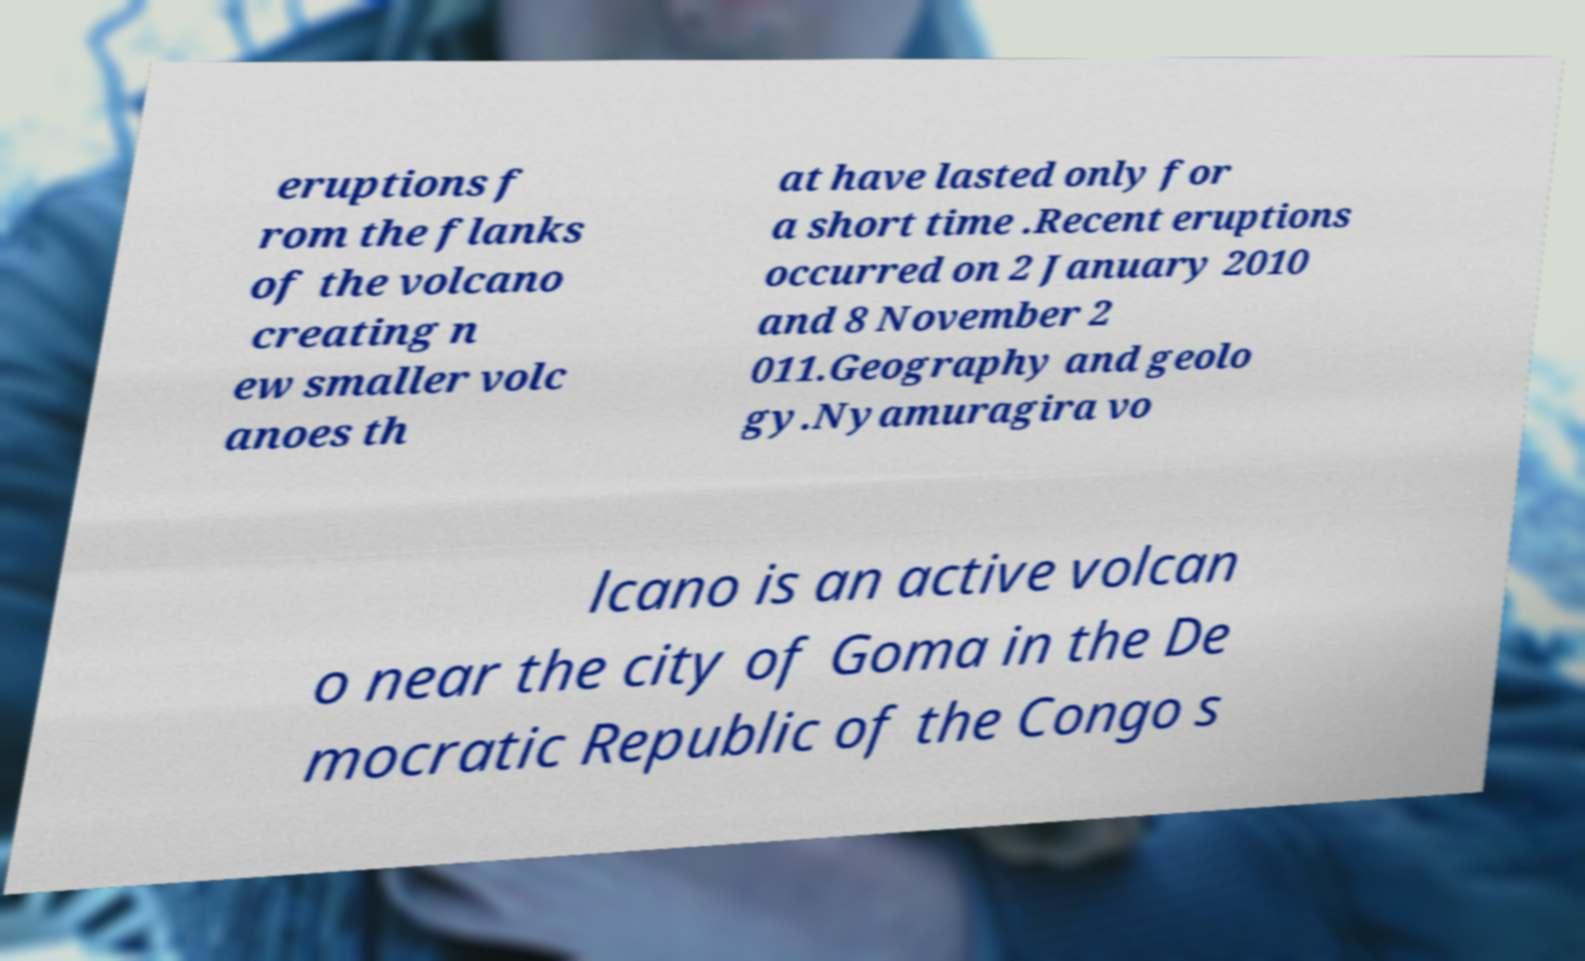What messages or text are displayed in this image? I need them in a readable, typed format. eruptions f rom the flanks of the volcano creating n ew smaller volc anoes th at have lasted only for a short time .Recent eruptions occurred on 2 January 2010 and 8 November 2 011.Geography and geolo gy.Nyamuragira vo lcano is an active volcan o near the city of Goma in the De mocratic Republic of the Congo s 